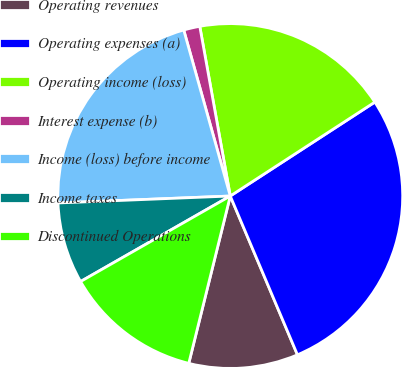Convert chart. <chart><loc_0><loc_0><loc_500><loc_500><pie_chart><fcel>Operating revenues<fcel>Operating expenses (a)<fcel>Operating income (loss)<fcel>Interest expense (b)<fcel>Income (loss) before income<fcel>Income taxes<fcel>Discontinued Operations<nl><fcel>10.24%<fcel>27.8%<fcel>18.66%<fcel>1.52%<fcel>21.29%<fcel>7.62%<fcel>12.87%<nl></chart> 